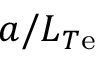Convert formula to latex. <formula><loc_0><loc_0><loc_500><loc_500>a / L _ { T e }</formula> 